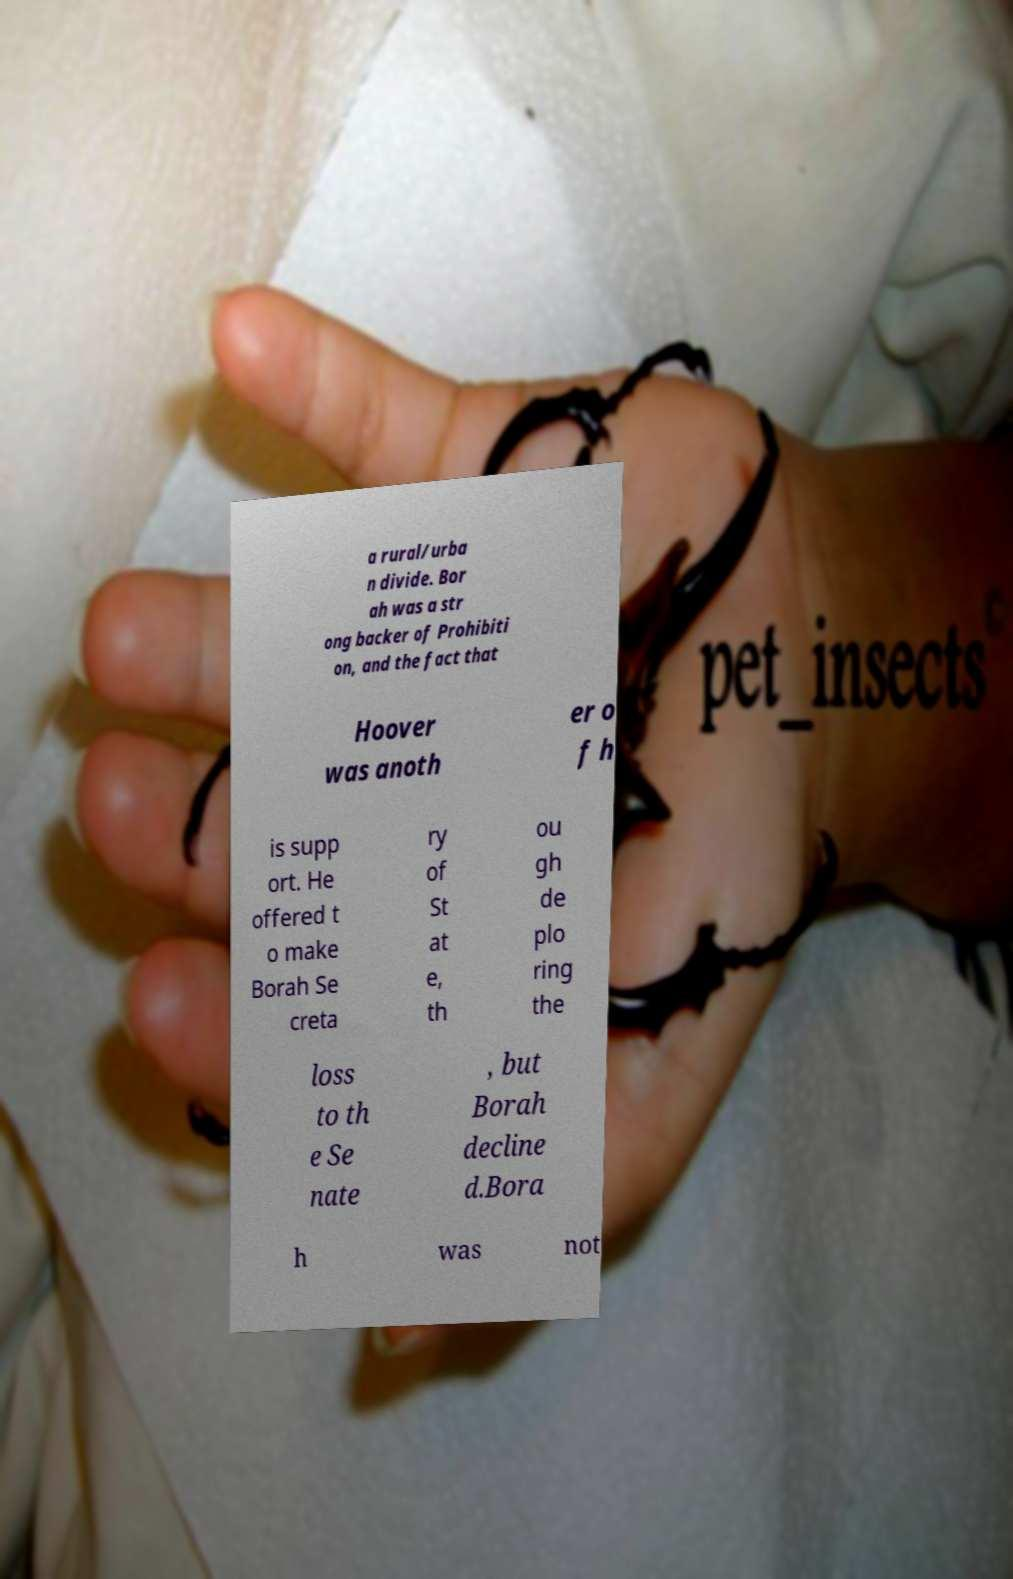There's text embedded in this image that I need extracted. Can you transcribe it verbatim? a rural/urba n divide. Bor ah was a str ong backer of Prohibiti on, and the fact that Hoover was anoth er o f h is supp ort. He offered t o make Borah Se creta ry of St at e, th ou gh de plo ring the loss to th e Se nate , but Borah decline d.Bora h was not 